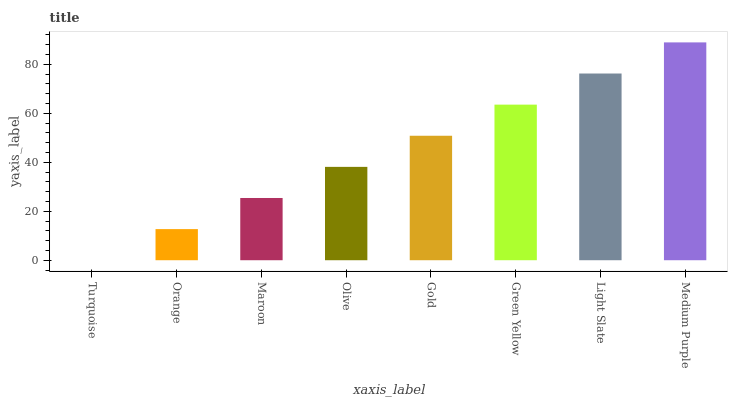Is Orange the minimum?
Answer yes or no. No. Is Orange the maximum?
Answer yes or no. No. Is Orange greater than Turquoise?
Answer yes or no. Yes. Is Turquoise less than Orange?
Answer yes or no. Yes. Is Turquoise greater than Orange?
Answer yes or no. No. Is Orange less than Turquoise?
Answer yes or no. No. Is Gold the high median?
Answer yes or no. Yes. Is Olive the low median?
Answer yes or no. Yes. Is Turquoise the high median?
Answer yes or no. No. Is Medium Purple the low median?
Answer yes or no. No. 